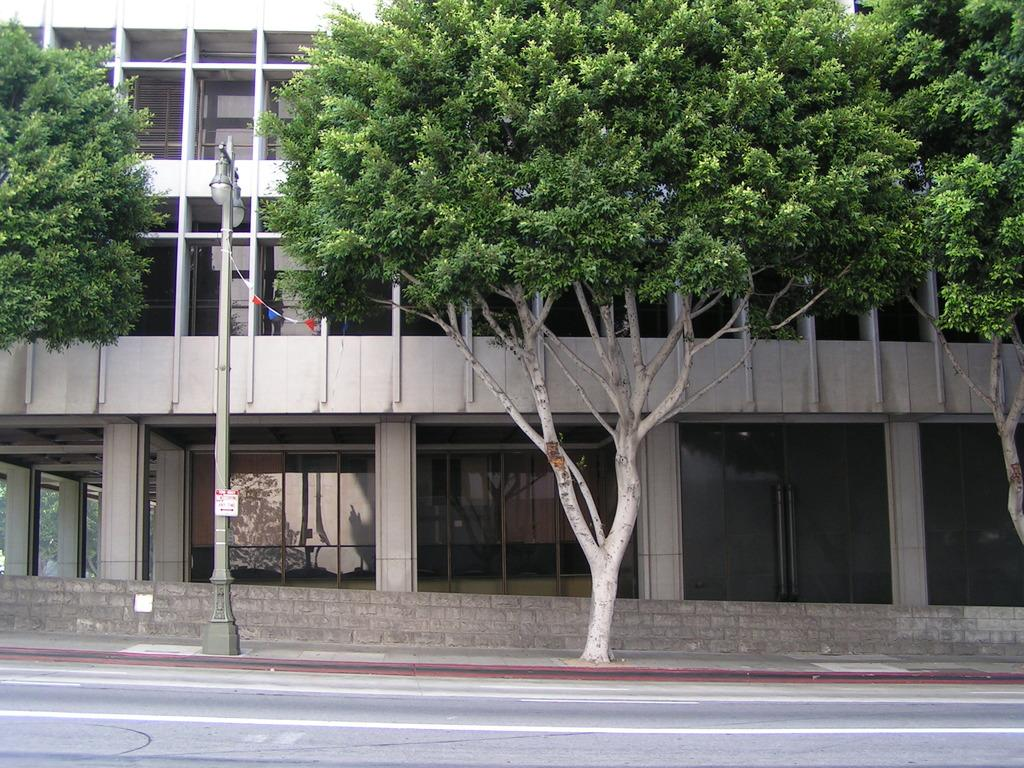What is the main structure in the center of the image? There is a building in the center of the image. What is a feature that allows people to enter the building? There is a door in the image. What allows natural light to enter the building? There are windows in the image. What material is used for the windows? Glass is present in the image. What separates the interior and exterior of the building? There is a wall in the image. What is a source of light visible in the image? An electric light pole is visible in the image. What type of vegetation is present in the image? Trees are present in the image. What is a flat surface with writing or images in the image? There is a board in the image. What is a path for vehicles or pedestrians at the bottom of the image? A road is at the bottom of the image. How many hands are visible holding the board in the image? There are no hands visible holding the board in the image. What type of care is being provided to the building in the image? The image does not show any care being provided to the building; it is a static representation. What kind of debt is associated with the building in the image? There is no information about any debt associated with the building in the image. 